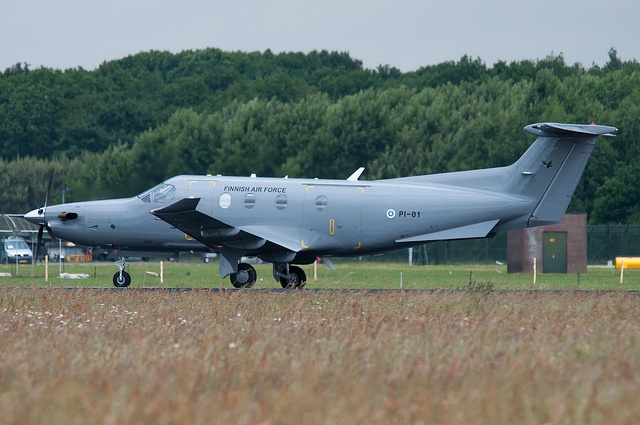Describe the objects in this image and their specific colors. I can see airplane in lightgray, black, gray, and darkgray tones and car in lightgray, gray, lavender, blue, and darkgray tones in this image. 